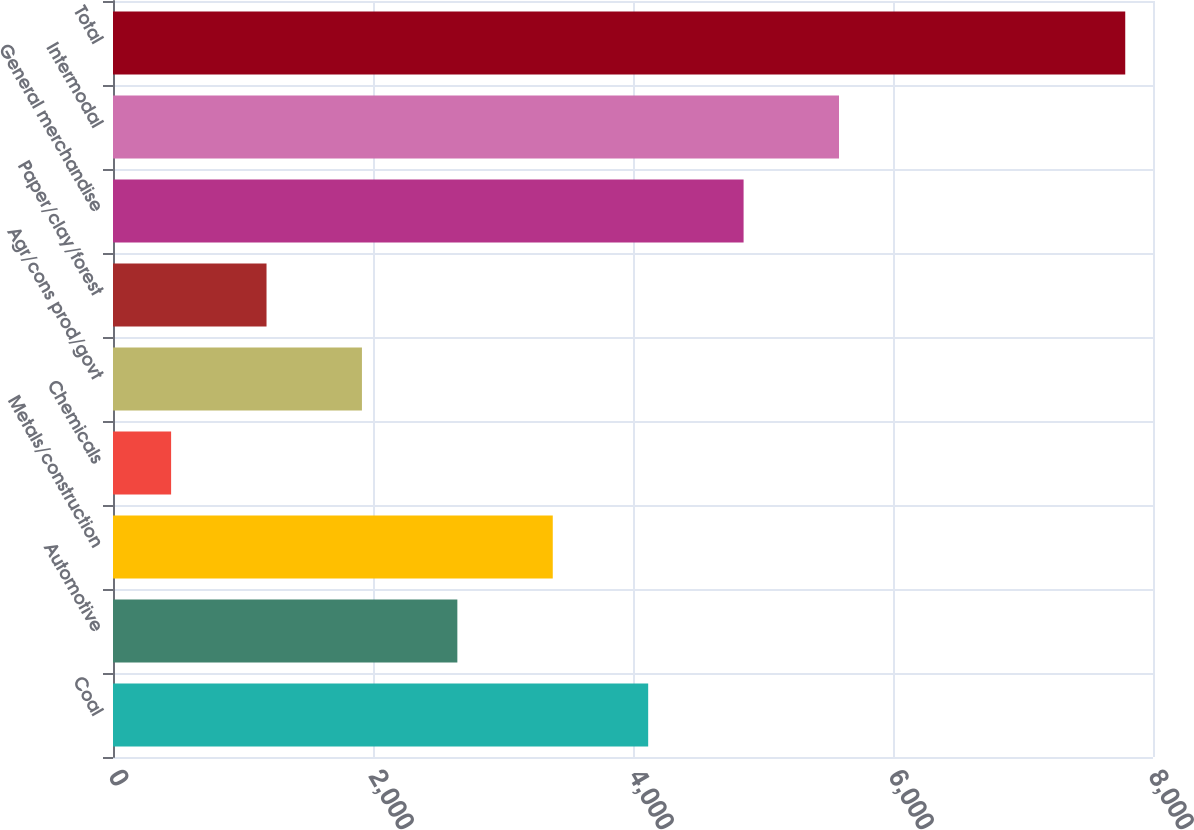Convert chart. <chart><loc_0><loc_0><loc_500><loc_500><bar_chart><fcel>Coal<fcel>Automotive<fcel>Metals/construction<fcel>Chemicals<fcel>Agr/cons prod/govt<fcel>Paper/clay/forest<fcel>General merchandise<fcel>Intermodal<fcel>Total<nl><fcel>4116.75<fcel>2648.85<fcel>3382.8<fcel>447<fcel>1914.9<fcel>1180.95<fcel>4850.7<fcel>5584.65<fcel>7786.5<nl></chart> 